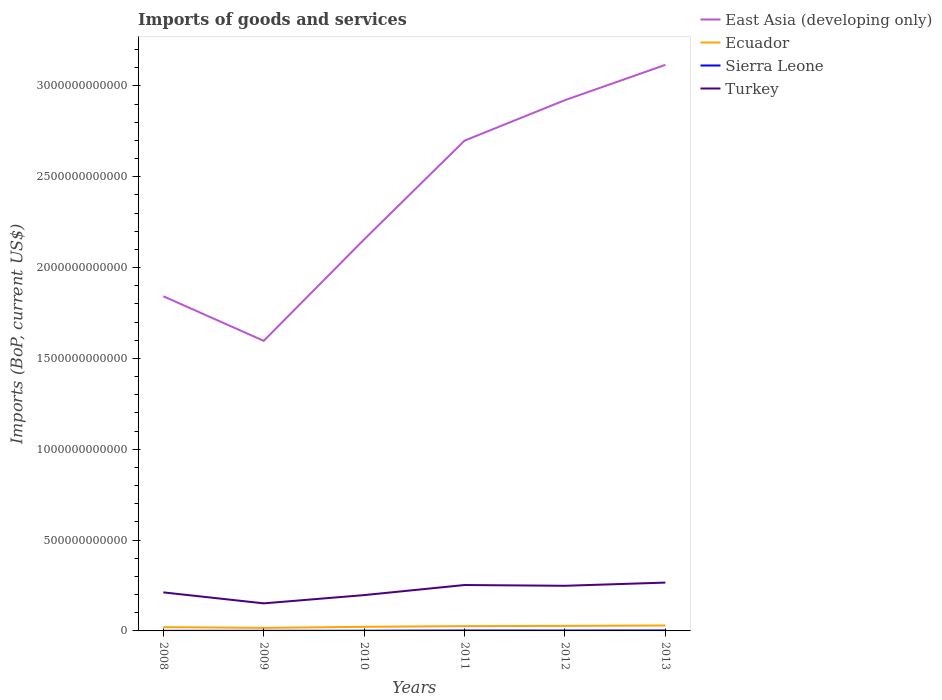Does the line corresponding to Sierra Leone intersect with the line corresponding to East Asia (developing only)?
Your answer should be very brief. No. Is the number of lines equal to the number of legend labels?
Your answer should be compact. Yes. Across all years, what is the maximum amount spent on imports in East Asia (developing only)?
Give a very brief answer. 1.60e+12. In which year was the amount spent on imports in Turkey maximum?
Keep it short and to the point. 2009. What is the total amount spent on imports in Sierra Leone in the graph?
Provide a short and direct response. -3.79e+08. What is the difference between the highest and the second highest amount spent on imports in Sierra Leone?
Offer a terse response. 2.06e+09. Is the amount spent on imports in Turkey strictly greater than the amount spent on imports in Sierra Leone over the years?
Your answer should be very brief. No. How many years are there in the graph?
Your answer should be very brief. 6. What is the difference between two consecutive major ticks on the Y-axis?
Your response must be concise. 5.00e+11. Are the values on the major ticks of Y-axis written in scientific E-notation?
Provide a short and direct response. No. Does the graph contain grids?
Your answer should be compact. No. How many legend labels are there?
Make the answer very short. 4. What is the title of the graph?
Make the answer very short. Imports of goods and services. What is the label or title of the X-axis?
Provide a short and direct response. Years. What is the label or title of the Y-axis?
Keep it short and to the point. Imports (BoP, current US$). What is the Imports (BoP, current US$) of East Asia (developing only) in 2008?
Provide a succinct answer. 1.84e+12. What is the Imports (BoP, current US$) of Ecuador in 2008?
Ensure brevity in your answer.  2.09e+1. What is the Imports (BoP, current US$) of Sierra Leone in 2008?
Provide a succinct answer. 5.92e+08. What is the Imports (BoP, current US$) in Turkey in 2008?
Offer a very short reply. 2.12e+11. What is the Imports (BoP, current US$) in East Asia (developing only) in 2009?
Provide a succinct answer. 1.60e+12. What is the Imports (BoP, current US$) in Ecuador in 2009?
Offer a very short reply. 1.69e+1. What is the Imports (BoP, current US$) in Sierra Leone in 2009?
Your answer should be compact. 7.50e+08. What is the Imports (BoP, current US$) in Turkey in 2009?
Your response must be concise. 1.52e+11. What is the Imports (BoP, current US$) in East Asia (developing only) in 2010?
Give a very brief answer. 2.16e+12. What is the Imports (BoP, current US$) in Ecuador in 2010?
Your answer should be very brief. 2.26e+1. What is the Imports (BoP, current US$) in Sierra Leone in 2010?
Keep it short and to the point. 1.13e+09. What is the Imports (BoP, current US$) of Turkey in 2010?
Give a very brief answer. 1.97e+11. What is the Imports (BoP, current US$) of East Asia (developing only) in 2011?
Offer a terse response. 2.70e+12. What is the Imports (BoP, current US$) in Ecuador in 2011?
Offer a very short reply. 2.64e+1. What is the Imports (BoP, current US$) in Sierra Leone in 2011?
Give a very brief answer. 2.48e+09. What is the Imports (BoP, current US$) in Turkey in 2011?
Offer a very short reply. 2.53e+11. What is the Imports (BoP, current US$) of East Asia (developing only) in 2012?
Give a very brief answer. 2.92e+12. What is the Imports (BoP, current US$) of Ecuador in 2012?
Offer a terse response. 2.77e+1. What is the Imports (BoP, current US$) of Sierra Leone in 2012?
Offer a terse response. 2.28e+09. What is the Imports (BoP, current US$) of Turkey in 2012?
Your answer should be compact. 2.48e+11. What is the Imports (BoP, current US$) of East Asia (developing only) in 2013?
Provide a succinct answer. 3.12e+12. What is the Imports (BoP, current US$) in Ecuador in 2013?
Your answer should be compact. 2.99e+1. What is the Imports (BoP, current US$) of Sierra Leone in 2013?
Your answer should be very brief. 2.66e+09. What is the Imports (BoP, current US$) of Turkey in 2013?
Give a very brief answer. 2.66e+11. Across all years, what is the maximum Imports (BoP, current US$) of East Asia (developing only)?
Offer a very short reply. 3.12e+12. Across all years, what is the maximum Imports (BoP, current US$) in Ecuador?
Provide a succinct answer. 2.99e+1. Across all years, what is the maximum Imports (BoP, current US$) of Sierra Leone?
Make the answer very short. 2.66e+09. Across all years, what is the maximum Imports (BoP, current US$) in Turkey?
Give a very brief answer. 2.66e+11. Across all years, what is the minimum Imports (BoP, current US$) of East Asia (developing only)?
Offer a terse response. 1.60e+12. Across all years, what is the minimum Imports (BoP, current US$) of Ecuador?
Ensure brevity in your answer.  1.69e+1. Across all years, what is the minimum Imports (BoP, current US$) of Sierra Leone?
Your answer should be very brief. 5.92e+08. Across all years, what is the minimum Imports (BoP, current US$) in Turkey?
Provide a succinct answer. 1.52e+11. What is the total Imports (BoP, current US$) in East Asia (developing only) in the graph?
Make the answer very short. 1.43e+13. What is the total Imports (BoP, current US$) of Ecuador in the graph?
Keep it short and to the point. 1.44e+11. What is the total Imports (BoP, current US$) of Sierra Leone in the graph?
Keep it short and to the point. 9.89e+09. What is the total Imports (BoP, current US$) of Turkey in the graph?
Ensure brevity in your answer.  1.33e+12. What is the difference between the Imports (BoP, current US$) in East Asia (developing only) in 2008 and that in 2009?
Keep it short and to the point. 2.45e+11. What is the difference between the Imports (BoP, current US$) of Ecuador in 2008 and that in 2009?
Ensure brevity in your answer.  4.04e+09. What is the difference between the Imports (BoP, current US$) in Sierra Leone in 2008 and that in 2009?
Make the answer very short. -1.57e+08. What is the difference between the Imports (BoP, current US$) of Turkey in 2008 and that in 2009?
Provide a succinct answer. 6.04e+1. What is the difference between the Imports (BoP, current US$) of East Asia (developing only) in 2008 and that in 2010?
Offer a very short reply. -3.13e+11. What is the difference between the Imports (BoP, current US$) of Ecuador in 2008 and that in 2010?
Your answer should be compact. -1.71e+09. What is the difference between the Imports (BoP, current US$) of Sierra Leone in 2008 and that in 2010?
Offer a terse response. -5.40e+08. What is the difference between the Imports (BoP, current US$) of Turkey in 2008 and that in 2010?
Provide a succinct answer. 1.50e+1. What is the difference between the Imports (BoP, current US$) of East Asia (developing only) in 2008 and that in 2011?
Keep it short and to the point. -8.57e+11. What is the difference between the Imports (BoP, current US$) of Ecuador in 2008 and that in 2011?
Offer a very short reply. -5.47e+09. What is the difference between the Imports (BoP, current US$) in Sierra Leone in 2008 and that in 2011?
Offer a terse response. -1.89e+09. What is the difference between the Imports (BoP, current US$) in Turkey in 2008 and that in 2011?
Offer a very short reply. -4.05e+1. What is the difference between the Imports (BoP, current US$) of East Asia (developing only) in 2008 and that in 2012?
Ensure brevity in your answer.  -1.08e+12. What is the difference between the Imports (BoP, current US$) in Ecuador in 2008 and that in 2012?
Your answer should be compact. -6.79e+09. What is the difference between the Imports (BoP, current US$) in Sierra Leone in 2008 and that in 2012?
Your response must be concise. -1.69e+09. What is the difference between the Imports (BoP, current US$) in Turkey in 2008 and that in 2012?
Your answer should be compact. -3.63e+1. What is the difference between the Imports (BoP, current US$) in East Asia (developing only) in 2008 and that in 2013?
Make the answer very short. -1.27e+12. What is the difference between the Imports (BoP, current US$) in Ecuador in 2008 and that in 2013?
Offer a very short reply. -8.94e+09. What is the difference between the Imports (BoP, current US$) in Sierra Leone in 2008 and that in 2013?
Make the answer very short. -2.06e+09. What is the difference between the Imports (BoP, current US$) of Turkey in 2008 and that in 2013?
Give a very brief answer. -5.38e+1. What is the difference between the Imports (BoP, current US$) in East Asia (developing only) in 2009 and that in 2010?
Your answer should be compact. -5.58e+11. What is the difference between the Imports (BoP, current US$) of Ecuador in 2009 and that in 2010?
Keep it short and to the point. -5.75e+09. What is the difference between the Imports (BoP, current US$) of Sierra Leone in 2009 and that in 2010?
Provide a succinct answer. -3.83e+08. What is the difference between the Imports (BoP, current US$) of Turkey in 2009 and that in 2010?
Provide a short and direct response. -4.54e+1. What is the difference between the Imports (BoP, current US$) in East Asia (developing only) in 2009 and that in 2011?
Offer a terse response. -1.10e+12. What is the difference between the Imports (BoP, current US$) of Ecuador in 2009 and that in 2011?
Offer a terse response. -9.51e+09. What is the difference between the Imports (BoP, current US$) of Sierra Leone in 2009 and that in 2011?
Your answer should be very brief. -1.73e+09. What is the difference between the Imports (BoP, current US$) in Turkey in 2009 and that in 2011?
Provide a succinct answer. -1.01e+11. What is the difference between the Imports (BoP, current US$) in East Asia (developing only) in 2009 and that in 2012?
Ensure brevity in your answer.  -1.32e+12. What is the difference between the Imports (BoP, current US$) of Ecuador in 2009 and that in 2012?
Make the answer very short. -1.08e+1. What is the difference between the Imports (BoP, current US$) of Sierra Leone in 2009 and that in 2012?
Offer a very short reply. -1.53e+09. What is the difference between the Imports (BoP, current US$) in Turkey in 2009 and that in 2012?
Offer a terse response. -9.67e+1. What is the difference between the Imports (BoP, current US$) in East Asia (developing only) in 2009 and that in 2013?
Offer a terse response. -1.52e+12. What is the difference between the Imports (BoP, current US$) of Ecuador in 2009 and that in 2013?
Your answer should be very brief. -1.30e+1. What is the difference between the Imports (BoP, current US$) of Sierra Leone in 2009 and that in 2013?
Your answer should be very brief. -1.91e+09. What is the difference between the Imports (BoP, current US$) of Turkey in 2009 and that in 2013?
Your response must be concise. -1.14e+11. What is the difference between the Imports (BoP, current US$) of East Asia (developing only) in 2010 and that in 2011?
Your answer should be very brief. -5.44e+11. What is the difference between the Imports (BoP, current US$) of Ecuador in 2010 and that in 2011?
Provide a short and direct response. -3.76e+09. What is the difference between the Imports (BoP, current US$) of Sierra Leone in 2010 and that in 2011?
Provide a succinct answer. -1.35e+09. What is the difference between the Imports (BoP, current US$) in Turkey in 2010 and that in 2011?
Offer a terse response. -5.55e+1. What is the difference between the Imports (BoP, current US$) of East Asia (developing only) in 2010 and that in 2012?
Keep it short and to the point. -7.67e+11. What is the difference between the Imports (BoP, current US$) of Ecuador in 2010 and that in 2012?
Keep it short and to the point. -5.08e+09. What is the difference between the Imports (BoP, current US$) of Sierra Leone in 2010 and that in 2012?
Ensure brevity in your answer.  -1.15e+09. What is the difference between the Imports (BoP, current US$) in Turkey in 2010 and that in 2012?
Ensure brevity in your answer.  -5.13e+1. What is the difference between the Imports (BoP, current US$) of East Asia (developing only) in 2010 and that in 2013?
Your response must be concise. -9.61e+11. What is the difference between the Imports (BoP, current US$) in Ecuador in 2010 and that in 2013?
Provide a short and direct response. -7.23e+09. What is the difference between the Imports (BoP, current US$) in Sierra Leone in 2010 and that in 2013?
Provide a short and direct response. -1.52e+09. What is the difference between the Imports (BoP, current US$) in Turkey in 2010 and that in 2013?
Your answer should be very brief. -6.88e+1. What is the difference between the Imports (BoP, current US$) of East Asia (developing only) in 2011 and that in 2012?
Keep it short and to the point. -2.23e+11. What is the difference between the Imports (BoP, current US$) in Ecuador in 2011 and that in 2012?
Your response must be concise. -1.32e+09. What is the difference between the Imports (BoP, current US$) in Sierra Leone in 2011 and that in 2012?
Offer a very short reply. 2.06e+08. What is the difference between the Imports (BoP, current US$) of Turkey in 2011 and that in 2012?
Offer a terse response. 4.24e+09. What is the difference between the Imports (BoP, current US$) in East Asia (developing only) in 2011 and that in 2013?
Ensure brevity in your answer.  -4.17e+11. What is the difference between the Imports (BoP, current US$) of Ecuador in 2011 and that in 2013?
Offer a very short reply. -3.47e+09. What is the difference between the Imports (BoP, current US$) of Sierra Leone in 2011 and that in 2013?
Ensure brevity in your answer.  -1.72e+08. What is the difference between the Imports (BoP, current US$) of Turkey in 2011 and that in 2013?
Provide a succinct answer. -1.33e+1. What is the difference between the Imports (BoP, current US$) in East Asia (developing only) in 2012 and that in 2013?
Your response must be concise. -1.94e+11. What is the difference between the Imports (BoP, current US$) in Ecuador in 2012 and that in 2013?
Offer a terse response. -2.14e+09. What is the difference between the Imports (BoP, current US$) of Sierra Leone in 2012 and that in 2013?
Ensure brevity in your answer.  -3.79e+08. What is the difference between the Imports (BoP, current US$) of Turkey in 2012 and that in 2013?
Offer a terse response. -1.75e+1. What is the difference between the Imports (BoP, current US$) in East Asia (developing only) in 2008 and the Imports (BoP, current US$) in Ecuador in 2009?
Provide a short and direct response. 1.83e+12. What is the difference between the Imports (BoP, current US$) in East Asia (developing only) in 2008 and the Imports (BoP, current US$) in Sierra Leone in 2009?
Provide a short and direct response. 1.84e+12. What is the difference between the Imports (BoP, current US$) in East Asia (developing only) in 2008 and the Imports (BoP, current US$) in Turkey in 2009?
Keep it short and to the point. 1.69e+12. What is the difference between the Imports (BoP, current US$) in Ecuador in 2008 and the Imports (BoP, current US$) in Sierra Leone in 2009?
Ensure brevity in your answer.  2.02e+1. What is the difference between the Imports (BoP, current US$) of Ecuador in 2008 and the Imports (BoP, current US$) of Turkey in 2009?
Offer a terse response. -1.31e+11. What is the difference between the Imports (BoP, current US$) in Sierra Leone in 2008 and the Imports (BoP, current US$) in Turkey in 2009?
Provide a short and direct response. -1.51e+11. What is the difference between the Imports (BoP, current US$) of East Asia (developing only) in 2008 and the Imports (BoP, current US$) of Ecuador in 2010?
Ensure brevity in your answer.  1.82e+12. What is the difference between the Imports (BoP, current US$) of East Asia (developing only) in 2008 and the Imports (BoP, current US$) of Sierra Leone in 2010?
Provide a succinct answer. 1.84e+12. What is the difference between the Imports (BoP, current US$) in East Asia (developing only) in 2008 and the Imports (BoP, current US$) in Turkey in 2010?
Keep it short and to the point. 1.64e+12. What is the difference between the Imports (BoP, current US$) of Ecuador in 2008 and the Imports (BoP, current US$) of Sierra Leone in 2010?
Provide a succinct answer. 1.98e+1. What is the difference between the Imports (BoP, current US$) in Ecuador in 2008 and the Imports (BoP, current US$) in Turkey in 2010?
Your answer should be very brief. -1.76e+11. What is the difference between the Imports (BoP, current US$) in Sierra Leone in 2008 and the Imports (BoP, current US$) in Turkey in 2010?
Keep it short and to the point. -1.97e+11. What is the difference between the Imports (BoP, current US$) of East Asia (developing only) in 2008 and the Imports (BoP, current US$) of Ecuador in 2011?
Your answer should be very brief. 1.82e+12. What is the difference between the Imports (BoP, current US$) of East Asia (developing only) in 2008 and the Imports (BoP, current US$) of Sierra Leone in 2011?
Offer a terse response. 1.84e+12. What is the difference between the Imports (BoP, current US$) in East Asia (developing only) in 2008 and the Imports (BoP, current US$) in Turkey in 2011?
Provide a short and direct response. 1.59e+12. What is the difference between the Imports (BoP, current US$) of Ecuador in 2008 and the Imports (BoP, current US$) of Sierra Leone in 2011?
Make the answer very short. 1.84e+1. What is the difference between the Imports (BoP, current US$) of Ecuador in 2008 and the Imports (BoP, current US$) of Turkey in 2011?
Your answer should be very brief. -2.32e+11. What is the difference between the Imports (BoP, current US$) in Sierra Leone in 2008 and the Imports (BoP, current US$) in Turkey in 2011?
Keep it short and to the point. -2.52e+11. What is the difference between the Imports (BoP, current US$) of East Asia (developing only) in 2008 and the Imports (BoP, current US$) of Ecuador in 2012?
Ensure brevity in your answer.  1.81e+12. What is the difference between the Imports (BoP, current US$) in East Asia (developing only) in 2008 and the Imports (BoP, current US$) in Sierra Leone in 2012?
Offer a very short reply. 1.84e+12. What is the difference between the Imports (BoP, current US$) of East Asia (developing only) in 2008 and the Imports (BoP, current US$) of Turkey in 2012?
Provide a short and direct response. 1.59e+12. What is the difference between the Imports (BoP, current US$) of Ecuador in 2008 and the Imports (BoP, current US$) of Sierra Leone in 2012?
Make the answer very short. 1.86e+1. What is the difference between the Imports (BoP, current US$) in Ecuador in 2008 and the Imports (BoP, current US$) in Turkey in 2012?
Offer a very short reply. -2.28e+11. What is the difference between the Imports (BoP, current US$) in Sierra Leone in 2008 and the Imports (BoP, current US$) in Turkey in 2012?
Offer a very short reply. -2.48e+11. What is the difference between the Imports (BoP, current US$) of East Asia (developing only) in 2008 and the Imports (BoP, current US$) of Ecuador in 2013?
Keep it short and to the point. 1.81e+12. What is the difference between the Imports (BoP, current US$) in East Asia (developing only) in 2008 and the Imports (BoP, current US$) in Sierra Leone in 2013?
Ensure brevity in your answer.  1.84e+12. What is the difference between the Imports (BoP, current US$) of East Asia (developing only) in 2008 and the Imports (BoP, current US$) of Turkey in 2013?
Offer a very short reply. 1.58e+12. What is the difference between the Imports (BoP, current US$) in Ecuador in 2008 and the Imports (BoP, current US$) in Sierra Leone in 2013?
Offer a terse response. 1.83e+1. What is the difference between the Imports (BoP, current US$) in Ecuador in 2008 and the Imports (BoP, current US$) in Turkey in 2013?
Offer a terse response. -2.45e+11. What is the difference between the Imports (BoP, current US$) in Sierra Leone in 2008 and the Imports (BoP, current US$) in Turkey in 2013?
Offer a very short reply. -2.65e+11. What is the difference between the Imports (BoP, current US$) in East Asia (developing only) in 2009 and the Imports (BoP, current US$) in Ecuador in 2010?
Make the answer very short. 1.57e+12. What is the difference between the Imports (BoP, current US$) of East Asia (developing only) in 2009 and the Imports (BoP, current US$) of Sierra Leone in 2010?
Keep it short and to the point. 1.60e+12. What is the difference between the Imports (BoP, current US$) in East Asia (developing only) in 2009 and the Imports (BoP, current US$) in Turkey in 2010?
Give a very brief answer. 1.40e+12. What is the difference between the Imports (BoP, current US$) in Ecuador in 2009 and the Imports (BoP, current US$) in Sierra Leone in 2010?
Offer a very short reply. 1.58e+1. What is the difference between the Imports (BoP, current US$) in Ecuador in 2009 and the Imports (BoP, current US$) in Turkey in 2010?
Your answer should be compact. -1.80e+11. What is the difference between the Imports (BoP, current US$) in Sierra Leone in 2009 and the Imports (BoP, current US$) in Turkey in 2010?
Keep it short and to the point. -1.96e+11. What is the difference between the Imports (BoP, current US$) of East Asia (developing only) in 2009 and the Imports (BoP, current US$) of Ecuador in 2011?
Make the answer very short. 1.57e+12. What is the difference between the Imports (BoP, current US$) of East Asia (developing only) in 2009 and the Imports (BoP, current US$) of Sierra Leone in 2011?
Your answer should be very brief. 1.59e+12. What is the difference between the Imports (BoP, current US$) of East Asia (developing only) in 2009 and the Imports (BoP, current US$) of Turkey in 2011?
Provide a succinct answer. 1.34e+12. What is the difference between the Imports (BoP, current US$) in Ecuador in 2009 and the Imports (BoP, current US$) in Sierra Leone in 2011?
Provide a succinct answer. 1.44e+1. What is the difference between the Imports (BoP, current US$) in Ecuador in 2009 and the Imports (BoP, current US$) in Turkey in 2011?
Make the answer very short. -2.36e+11. What is the difference between the Imports (BoP, current US$) in Sierra Leone in 2009 and the Imports (BoP, current US$) in Turkey in 2011?
Offer a terse response. -2.52e+11. What is the difference between the Imports (BoP, current US$) in East Asia (developing only) in 2009 and the Imports (BoP, current US$) in Ecuador in 2012?
Provide a succinct answer. 1.57e+12. What is the difference between the Imports (BoP, current US$) of East Asia (developing only) in 2009 and the Imports (BoP, current US$) of Sierra Leone in 2012?
Keep it short and to the point. 1.59e+12. What is the difference between the Imports (BoP, current US$) in East Asia (developing only) in 2009 and the Imports (BoP, current US$) in Turkey in 2012?
Give a very brief answer. 1.35e+12. What is the difference between the Imports (BoP, current US$) of Ecuador in 2009 and the Imports (BoP, current US$) of Sierra Leone in 2012?
Offer a terse response. 1.46e+1. What is the difference between the Imports (BoP, current US$) in Ecuador in 2009 and the Imports (BoP, current US$) in Turkey in 2012?
Keep it short and to the point. -2.32e+11. What is the difference between the Imports (BoP, current US$) of Sierra Leone in 2009 and the Imports (BoP, current US$) of Turkey in 2012?
Offer a terse response. -2.48e+11. What is the difference between the Imports (BoP, current US$) in East Asia (developing only) in 2009 and the Imports (BoP, current US$) in Ecuador in 2013?
Offer a terse response. 1.57e+12. What is the difference between the Imports (BoP, current US$) of East Asia (developing only) in 2009 and the Imports (BoP, current US$) of Sierra Leone in 2013?
Your answer should be very brief. 1.59e+12. What is the difference between the Imports (BoP, current US$) of East Asia (developing only) in 2009 and the Imports (BoP, current US$) of Turkey in 2013?
Keep it short and to the point. 1.33e+12. What is the difference between the Imports (BoP, current US$) in Ecuador in 2009 and the Imports (BoP, current US$) in Sierra Leone in 2013?
Your answer should be very brief. 1.42e+1. What is the difference between the Imports (BoP, current US$) of Ecuador in 2009 and the Imports (BoP, current US$) of Turkey in 2013?
Offer a terse response. -2.49e+11. What is the difference between the Imports (BoP, current US$) of Sierra Leone in 2009 and the Imports (BoP, current US$) of Turkey in 2013?
Offer a terse response. -2.65e+11. What is the difference between the Imports (BoP, current US$) in East Asia (developing only) in 2010 and the Imports (BoP, current US$) in Ecuador in 2011?
Your answer should be very brief. 2.13e+12. What is the difference between the Imports (BoP, current US$) in East Asia (developing only) in 2010 and the Imports (BoP, current US$) in Sierra Leone in 2011?
Ensure brevity in your answer.  2.15e+12. What is the difference between the Imports (BoP, current US$) in East Asia (developing only) in 2010 and the Imports (BoP, current US$) in Turkey in 2011?
Your answer should be compact. 1.90e+12. What is the difference between the Imports (BoP, current US$) of Ecuador in 2010 and the Imports (BoP, current US$) of Sierra Leone in 2011?
Keep it short and to the point. 2.02e+1. What is the difference between the Imports (BoP, current US$) of Ecuador in 2010 and the Imports (BoP, current US$) of Turkey in 2011?
Offer a terse response. -2.30e+11. What is the difference between the Imports (BoP, current US$) in Sierra Leone in 2010 and the Imports (BoP, current US$) in Turkey in 2011?
Your answer should be compact. -2.52e+11. What is the difference between the Imports (BoP, current US$) in East Asia (developing only) in 2010 and the Imports (BoP, current US$) in Ecuador in 2012?
Provide a short and direct response. 2.13e+12. What is the difference between the Imports (BoP, current US$) of East Asia (developing only) in 2010 and the Imports (BoP, current US$) of Sierra Leone in 2012?
Provide a short and direct response. 2.15e+12. What is the difference between the Imports (BoP, current US$) of East Asia (developing only) in 2010 and the Imports (BoP, current US$) of Turkey in 2012?
Ensure brevity in your answer.  1.91e+12. What is the difference between the Imports (BoP, current US$) in Ecuador in 2010 and the Imports (BoP, current US$) in Sierra Leone in 2012?
Offer a terse response. 2.04e+1. What is the difference between the Imports (BoP, current US$) of Ecuador in 2010 and the Imports (BoP, current US$) of Turkey in 2012?
Your answer should be very brief. -2.26e+11. What is the difference between the Imports (BoP, current US$) of Sierra Leone in 2010 and the Imports (BoP, current US$) of Turkey in 2012?
Ensure brevity in your answer.  -2.47e+11. What is the difference between the Imports (BoP, current US$) in East Asia (developing only) in 2010 and the Imports (BoP, current US$) in Ecuador in 2013?
Offer a very short reply. 2.13e+12. What is the difference between the Imports (BoP, current US$) in East Asia (developing only) in 2010 and the Imports (BoP, current US$) in Sierra Leone in 2013?
Give a very brief answer. 2.15e+12. What is the difference between the Imports (BoP, current US$) of East Asia (developing only) in 2010 and the Imports (BoP, current US$) of Turkey in 2013?
Offer a terse response. 1.89e+12. What is the difference between the Imports (BoP, current US$) of Ecuador in 2010 and the Imports (BoP, current US$) of Sierra Leone in 2013?
Keep it short and to the point. 2.00e+1. What is the difference between the Imports (BoP, current US$) in Ecuador in 2010 and the Imports (BoP, current US$) in Turkey in 2013?
Your answer should be very brief. -2.43e+11. What is the difference between the Imports (BoP, current US$) of Sierra Leone in 2010 and the Imports (BoP, current US$) of Turkey in 2013?
Offer a very short reply. -2.65e+11. What is the difference between the Imports (BoP, current US$) of East Asia (developing only) in 2011 and the Imports (BoP, current US$) of Ecuador in 2012?
Your response must be concise. 2.67e+12. What is the difference between the Imports (BoP, current US$) in East Asia (developing only) in 2011 and the Imports (BoP, current US$) in Sierra Leone in 2012?
Make the answer very short. 2.70e+12. What is the difference between the Imports (BoP, current US$) of East Asia (developing only) in 2011 and the Imports (BoP, current US$) of Turkey in 2012?
Make the answer very short. 2.45e+12. What is the difference between the Imports (BoP, current US$) of Ecuador in 2011 and the Imports (BoP, current US$) of Sierra Leone in 2012?
Your answer should be compact. 2.41e+1. What is the difference between the Imports (BoP, current US$) in Ecuador in 2011 and the Imports (BoP, current US$) in Turkey in 2012?
Ensure brevity in your answer.  -2.22e+11. What is the difference between the Imports (BoP, current US$) in Sierra Leone in 2011 and the Imports (BoP, current US$) in Turkey in 2012?
Offer a terse response. -2.46e+11. What is the difference between the Imports (BoP, current US$) of East Asia (developing only) in 2011 and the Imports (BoP, current US$) of Ecuador in 2013?
Make the answer very short. 2.67e+12. What is the difference between the Imports (BoP, current US$) of East Asia (developing only) in 2011 and the Imports (BoP, current US$) of Sierra Leone in 2013?
Offer a terse response. 2.70e+12. What is the difference between the Imports (BoP, current US$) of East Asia (developing only) in 2011 and the Imports (BoP, current US$) of Turkey in 2013?
Ensure brevity in your answer.  2.43e+12. What is the difference between the Imports (BoP, current US$) in Ecuador in 2011 and the Imports (BoP, current US$) in Sierra Leone in 2013?
Make the answer very short. 2.37e+1. What is the difference between the Imports (BoP, current US$) in Ecuador in 2011 and the Imports (BoP, current US$) in Turkey in 2013?
Provide a short and direct response. -2.40e+11. What is the difference between the Imports (BoP, current US$) in Sierra Leone in 2011 and the Imports (BoP, current US$) in Turkey in 2013?
Keep it short and to the point. -2.64e+11. What is the difference between the Imports (BoP, current US$) of East Asia (developing only) in 2012 and the Imports (BoP, current US$) of Ecuador in 2013?
Offer a very short reply. 2.89e+12. What is the difference between the Imports (BoP, current US$) in East Asia (developing only) in 2012 and the Imports (BoP, current US$) in Sierra Leone in 2013?
Your answer should be compact. 2.92e+12. What is the difference between the Imports (BoP, current US$) of East Asia (developing only) in 2012 and the Imports (BoP, current US$) of Turkey in 2013?
Offer a terse response. 2.66e+12. What is the difference between the Imports (BoP, current US$) in Ecuador in 2012 and the Imports (BoP, current US$) in Sierra Leone in 2013?
Your answer should be compact. 2.51e+1. What is the difference between the Imports (BoP, current US$) of Ecuador in 2012 and the Imports (BoP, current US$) of Turkey in 2013?
Make the answer very short. -2.38e+11. What is the difference between the Imports (BoP, current US$) of Sierra Leone in 2012 and the Imports (BoP, current US$) of Turkey in 2013?
Offer a terse response. -2.64e+11. What is the average Imports (BoP, current US$) of East Asia (developing only) per year?
Offer a very short reply. 2.39e+12. What is the average Imports (BoP, current US$) in Ecuador per year?
Offer a terse response. 2.41e+1. What is the average Imports (BoP, current US$) in Sierra Leone per year?
Give a very brief answer. 1.65e+09. What is the average Imports (BoP, current US$) in Turkey per year?
Ensure brevity in your answer.  2.21e+11. In the year 2008, what is the difference between the Imports (BoP, current US$) of East Asia (developing only) and Imports (BoP, current US$) of Ecuador?
Your answer should be very brief. 1.82e+12. In the year 2008, what is the difference between the Imports (BoP, current US$) of East Asia (developing only) and Imports (BoP, current US$) of Sierra Leone?
Provide a succinct answer. 1.84e+12. In the year 2008, what is the difference between the Imports (BoP, current US$) in East Asia (developing only) and Imports (BoP, current US$) in Turkey?
Provide a short and direct response. 1.63e+12. In the year 2008, what is the difference between the Imports (BoP, current US$) in Ecuador and Imports (BoP, current US$) in Sierra Leone?
Provide a succinct answer. 2.03e+1. In the year 2008, what is the difference between the Imports (BoP, current US$) of Ecuador and Imports (BoP, current US$) of Turkey?
Your answer should be very brief. -1.91e+11. In the year 2008, what is the difference between the Imports (BoP, current US$) in Sierra Leone and Imports (BoP, current US$) in Turkey?
Keep it short and to the point. -2.12e+11. In the year 2009, what is the difference between the Imports (BoP, current US$) in East Asia (developing only) and Imports (BoP, current US$) in Ecuador?
Ensure brevity in your answer.  1.58e+12. In the year 2009, what is the difference between the Imports (BoP, current US$) of East Asia (developing only) and Imports (BoP, current US$) of Sierra Leone?
Give a very brief answer. 1.60e+12. In the year 2009, what is the difference between the Imports (BoP, current US$) in East Asia (developing only) and Imports (BoP, current US$) in Turkey?
Offer a very short reply. 1.45e+12. In the year 2009, what is the difference between the Imports (BoP, current US$) in Ecuador and Imports (BoP, current US$) in Sierra Leone?
Keep it short and to the point. 1.61e+1. In the year 2009, what is the difference between the Imports (BoP, current US$) in Ecuador and Imports (BoP, current US$) in Turkey?
Keep it short and to the point. -1.35e+11. In the year 2009, what is the difference between the Imports (BoP, current US$) in Sierra Leone and Imports (BoP, current US$) in Turkey?
Provide a succinct answer. -1.51e+11. In the year 2010, what is the difference between the Imports (BoP, current US$) of East Asia (developing only) and Imports (BoP, current US$) of Ecuador?
Offer a terse response. 2.13e+12. In the year 2010, what is the difference between the Imports (BoP, current US$) in East Asia (developing only) and Imports (BoP, current US$) in Sierra Leone?
Ensure brevity in your answer.  2.15e+12. In the year 2010, what is the difference between the Imports (BoP, current US$) of East Asia (developing only) and Imports (BoP, current US$) of Turkey?
Ensure brevity in your answer.  1.96e+12. In the year 2010, what is the difference between the Imports (BoP, current US$) in Ecuador and Imports (BoP, current US$) in Sierra Leone?
Your answer should be very brief. 2.15e+1. In the year 2010, what is the difference between the Imports (BoP, current US$) in Ecuador and Imports (BoP, current US$) in Turkey?
Ensure brevity in your answer.  -1.75e+11. In the year 2010, what is the difference between the Imports (BoP, current US$) of Sierra Leone and Imports (BoP, current US$) of Turkey?
Ensure brevity in your answer.  -1.96e+11. In the year 2011, what is the difference between the Imports (BoP, current US$) in East Asia (developing only) and Imports (BoP, current US$) in Ecuador?
Provide a short and direct response. 2.67e+12. In the year 2011, what is the difference between the Imports (BoP, current US$) in East Asia (developing only) and Imports (BoP, current US$) in Sierra Leone?
Your answer should be very brief. 2.70e+12. In the year 2011, what is the difference between the Imports (BoP, current US$) of East Asia (developing only) and Imports (BoP, current US$) of Turkey?
Make the answer very short. 2.45e+12. In the year 2011, what is the difference between the Imports (BoP, current US$) in Ecuador and Imports (BoP, current US$) in Sierra Leone?
Provide a succinct answer. 2.39e+1. In the year 2011, what is the difference between the Imports (BoP, current US$) in Ecuador and Imports (BoP, current US$) in Turkey?
Provide a succinct answer. -2.26e+11. In the year 2011, what is the difference between the Imports (BoP, current US$) of Sierra Leone and Imports (BoP, current US$) of Turkey?
Offer a terse response. -2.50e+11. In the year 2012, what is the difference between the Imports (BoP, current US$) in East Asia (developing only) and Imports (BoP, current US$) in Ecuador?
Keep it short and to the point. 2.89e+12. In the year 2012, what is the difference between the Imports (BoP, current US$) of East Asia (developing only) and Imports (BoP, current US$) of Sierra Leone?
Your answer should be compact. 2.92e+12. In the year 2012, what is the difference between the Imports (BoP, current US$) in East Asia (developing only) and Imports (BoP, current US$) in Turkey?
Your answer should be compact. 2.67e+12. In the year 2012, what is the difference between the Imports (BoP, current US$) of Ecuador and Imports (BoP, current US$) of Sierra Leone?
Your answer should be very brief. 2.54e+1. In the year 2012, what is the difference between the Imports (BoP, current US$) of Ecuador and Imports (BoP, current US$) of Turkey?
Your answer should be compact. -2.21e+11. In the year 2012, what is the difference between the Imports (BoP, current US$) in Sierra Leone and Imports (BoP, current US$) in Turkey?
Your response must be concise. -2.46e+11. In the year 2013, what is the difference between the Imports (BoP, current US$) in East Asia (developing only) and Imports (BoP, current US$) in Ecuador?
Your answer should be very brief. 3.09e+12. In the year 2013, what is the difference between the Imports (BoP, current US$) of East Asia (developing only) and Imports (BoP, current US$) of Sierra Leone?
Offer a terse response. 3.11e+12. In the year 2013, what is the difference between the Imports (BoP, current US$) of East Asia (developing only) and Imports (BoP, current US$) of Turkey?
Provide a succinct answer. 2.85e+12. In the year 2013, what is the difference between the Imports (BoP, current US$) of Ecuador and Imports (BoP, current US$) of Sierra Leone?
Provide a succinct answer. 2.72e+1. In the year 2013, what is the difference between the Imports (BoP, current US$) in Ecuador and Imports (BoP, current US$) in Turkey?
Offer a terse response. -2.36e+11. In the year 2013, what is the difference between the Imports (BoP, current US$) in Sierra Leone and Imports (BoP, current US$) in Turkey?
Your answer should be very brief. -2.63e+11. What is the ratio of the Imports (BoP, current US$) of East Asia (developing only) in 2008 to that in 2009?
Your answer should be compact. 1.15. What is the ratio of the Imports (BoP, current US$) in Ecuador in 2008 to that in 2009?
Offer a terse response. 1.24. What is the ratio of the Imports (BoP, current US$) in Sierra Leone in 2008 to that in 2009?
Offer a very short reply. 0.79. What is the ratio of the Imports (BoP, current US$) in Turkey in 2008 to that in 2009?
Make the answer very short. 1.4. What is the ratio of the Imports (BoP, current US$) in East Asia (developing only) in 2008 to that in 2010?
Your answer should be very brief. 0.85. What is the ratio of the Imports (BoP, current US$) of Ecuador in 2008 to that in 2010?
Your response must be concise. 0.92. What is the ratio of the Imports (BoP, current US$) of Sierra Leone in 2008 to that in 2010?
Keep it short and to the point. 0.52. What is the ratio of the Imports (BoP, current US$) in Turkey in 2008 to that in 2010?
Ensure brevity in your answer.  1.08. What is the ratio of the Imports (BoP, current US$) in East Asia (developing only) in 2008 to that in 2011?
Make the answer very short. 0.68. What is the ratio of the Imports (BoP, current US$) of Ecuador in 2008 to that in 2011?
Make the answer very short. 0.79. What is the ratio of the Imports (BoP, current US$) of Sierra Leone in 2008 to that in 2011?
Give a very brief answer. 0.24. What is the ratio of the Imports (BoP, current US$) in Turkey in 2008 to that in 2011?
Keep it short and to the point. 0.84. What is the ratio of the Imports (BoP, current US$) in East Asia (developing only) in 2008 to that in 2012?
Make the answer very short. 0.63. What is the ratio of the Imports (BoP, current US$) of Ecuador in 2008 to that in 2012?
Provide a succinct answer. 0.75. What is the ratio of the Imports (BoP, current US$) in Sierra Leone in 2008 to that in 2012?
Offer a very short reply. 0.26. What is the ratio of the Imports (BoP, current US$) in Turkey in 2008 to that in 2012?
Your response must be concise. 0.85. What is the ratio of the Imports (BoP, current US$) of East Asia (developing only) in 2008 to that in 2013?
Your answer should be very brief. 0.59. What is the ratio of the Imports (BoP, current US$) of Ecuador in 2008 to that in 2013?
Provide a succinct answer. 0.7. What is the ratio of the Imports (BoP, current US$) of Sierra Leone in 2008 to that in 2013?
Your answer should be very brief. 0.22. What is the ratio of the Imports (BoP, current US$) in Turkey in 2008 to that in 2013?
Provide a short and direct response. 0.8. What is the ratio of the Imports (BoP, current US$) in East Asia (developing only) in 2009 to that in 2010?
Give a very brief answer. 0.74. What is the ratio of the Imports (BoP, current US$) in Ecuador in 2009 to that in 2010?
Give a very brief answer. 0.75. What is the ratio of the Imports (BoP, current US$) in Sierra Leone in 2009 to that in 2010?
Offer a terse response. 0.66. What is the ratio of the Imports (BoP, current US$) of Turkey in 2009 to that in 2010?
Offer a very short reply. 0.77. What is the ratio of the Imports (BoP, current US$) of East Asia (developing only) in 2009 to that in 2011?
Offer a terse response. 0.59. What is the ratio of the Imports (BoP, current US$) of Ecuador in 2009 to that in 2011?
Provide a succinct answer. 0.64. What is the ratio of the Imports (BoP, current US$) in Sierra Leone in 2009 to that in 2011?
Make the answer very short. 0.3. What is the ratio of the Imports (BoP, current US$) in Turkey in 2009 to that in 2011?
Give a very brief answer. 0.6. What is the ratio of the Imports (BoP, current US$) in East Asia (developing only) in 2009 to that in 2012?
Provide a succinct answer. 0.55. What is the ratio of the Imports (BoP, current US$) of Ecuador in 2009 to that in 2012?
Keep it short and to the point. 0.61. What is the ratio of the Imports (BoP, current US$) in Sierra Leone in 2009 to that in 2012?
Your answer should be compact. 0.33. What is the ratio of the Imports (BoP, current US$) of Turkey in 2009 to that in 2012?
Your answer should be compact. 0.61. What is the ratio of the Imports (BoP, current US$) in East Asia (developing only) in 2009 to that in 2013?
Offer a very short reply. 0.51. What is the ratio of the Imports (BoP, current US$) of Ecuador in 2009 to that in 2013?
Offer a terse response. 0.57. What is the ratio of the Imports (BoP, current US$) of Sierra Leone in 2009 to that in 2013?
Your answer should be compact. 0.28. What is the ratio of the Imports (BoP, current US$) in Turkey in 2009 to that in 2013?
Provide a succinct answer. 0.57. What is the ratio of the Imports (BoP, current US$) in East Asia (developing only) in 2010 to that in 2011?
Your answer should be very brief. 0.8. What is the ratio of the Imports (BoP, current US$) in Ecuador in 2010 to that in 2011?
Keep it short and to the point. 0.86. What is the ratio of the Imports (BoP, current US$) of Sierra Leone in 2010 to that in 2011?
Provide a short and direct response. 0.46. What is the ratio of the Imports (BoP, current US$) of Turkey in 2010 to that in 2011?
Your response must be concise. 0.78. What is the ratio of the Imports (BoP, current US$) of East Asia (developing only) in 2010 to that in 2012?
Your answer should be compact. 0.74. What is the ratio of the Imports (BoP, current US$) in Ecuador in 2010 to that in 2012?
Offer a terse response. 0.82. What is the ratio of the Imports (BoP, current US$) of Sierra Leone in 2010 to that in 2012?
Make the answer very short. 0.5. What is the ratio of the Imports (BoP, current US$) in Turkey in 2010 to that in 2012?
Your response must be concise. 0.79. What is the ratio of the Imports (BoP, current US$) of East Asia (developing only) in 2010 to that in 2013?
Give a very brief answer. 0.69. What is the ratio of the Imports (BoP, current US$) of Ecuador in 2010 to that in 2013?
Your answer should be compact. 0.76. What is the ratio of the Imports (BoP, current US$) in Sierra Leone in 2010 to that in 2013?
Provide a short and direct response. 0.43. What is the ratio of the Imports (BoP, current US$) of Turkey in 2010 to that in 2013?
Offer a terse response. 0.74. What is the ratio of the Imports (BoP, current US$) in East Asia (developing only) in 2011 to that in 2012?
Provide a succinct answer. 0.92. What is the ratio of the Imports (BoP, current US$) in Ecuador in 2011 to that in 2012?
Offer a very short reply. 0.95. What is the ratio of the Imports (BoP, current US$) in Sierra Leone in 2011 to that in 2012?
Offer a terse response. 1.09. What is the ratio of the Imports (BoP, current US$) in East Asia (developing only) in 2011 to that in 2013?
Keep it short and to the point. 0.87. What is the ratio of the Imports (BoP, current US$) in Ecuador in 2011 to that in 2013?
Ensure brevity in your answer.  0.88. What is the ratio of the Imports (BoP, current US$) of Sierra Leone in 2011 to that in 2013?
Offer a terse response. 0.94. What is the ratio of the Imports (BoP, current US$) of Turkey in 2011 to that in 2013?
Give a very brief answer. 0.95. What is the ratio of the Imports (BoP, current US$) in East Asia (developing only) in 2012 to that in 2013?
Offer a very short reply. 0.94. What is the ratio of the Imports (BoP, current US$) of Ecuador in 2012 to that in 2013?
Give a very brief answer. 0.93. What is the ratio of the Imports (BoP, current US$) in Sierra Leone in 2012 to that in 2013?
Provide a short and direct response. 0.86. What is the ratio of the Imports (BoP, current US$) in Turkey in 2012 to that in 2013?
Your answer should be very brief. 0.93. What is the difference between the highest and the second highest Imports (BoP, current US$) of East Asia (developing only)?
Make the answer very short. 1.94e+11. What is the difference between the highest and the second highest Imports (BoP, current US$) of Ecuador?
Provide a succinct answer. 2.14e+09. What is the difference between the highest and the second highest Imports (BoP, current US$) of Sierra Leone?
Ensure brevity in your answer.  1.72e+08. What is the difference between the highest and the second highest Imports (BoP, current US$) in Turkey?
Keep it short and to the point. 1.33e+1. What is the difference between the highest and the lowest Imports (BoP, current US$) in East Asia (developing only)?
Offer a terse response. 1.52e+12. What is the difference between the highest and the lowest Imports (BoP, current US$) in Ecuador?
Your response must be concise. 1.30e+1. What is the difference between the highest and the lowest Imports (BoP, current US$) of Sierra Leone?
Offer a terse response. 2.06e+09. What is the difference between the highest and the lowest Imports (BoP, current US$) of Turkey?
Give a very brief answer. 1.14e+11. 